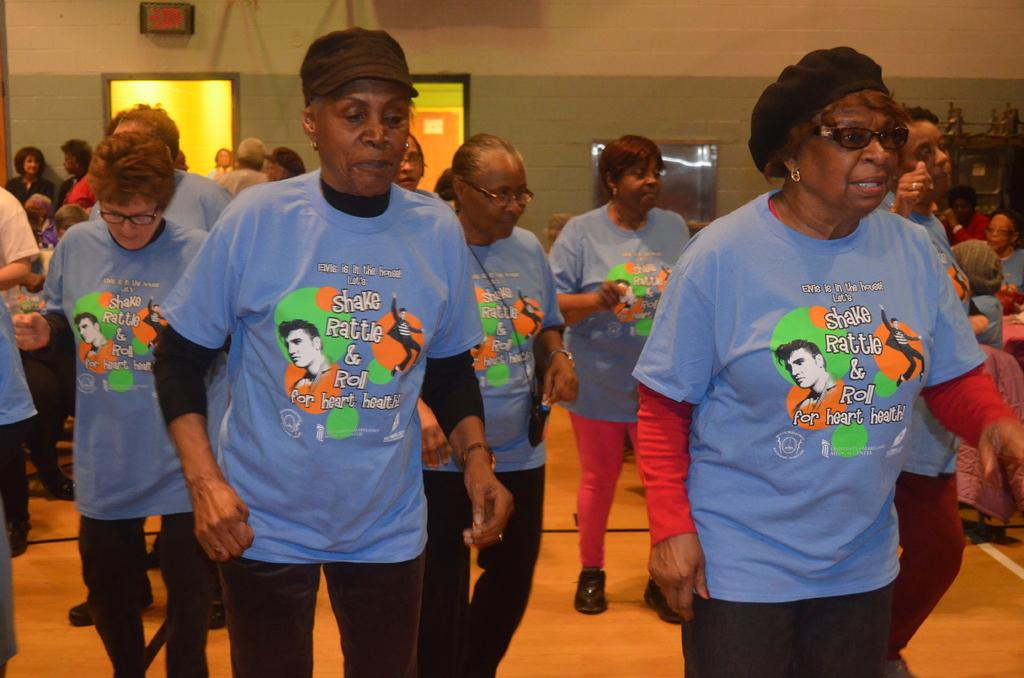How many people are in the image? There are persons standing in the image. What is the surface on which the persons are standing? The persons are standing on the floor. What can be seen in the background of the image? There is a sign board, walls, and windows in the background of the image. What type of church is being discussed in the meeting in the image? There is no church or meeting present in the image; it features persons standing on the floor with a background that includes a sign board, walls, and windows. 